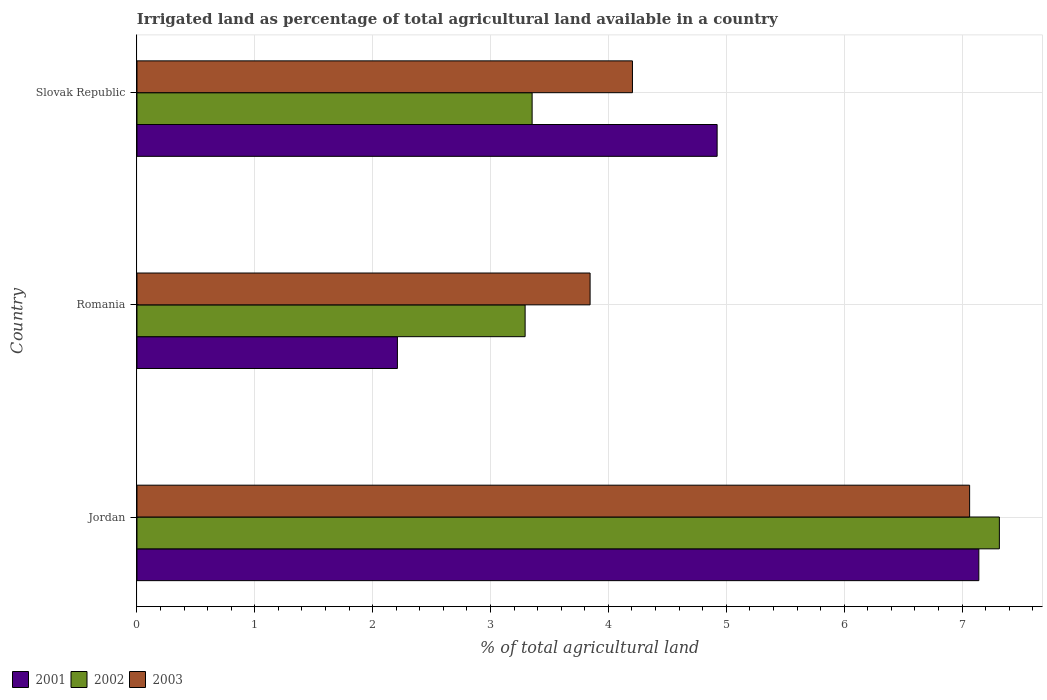Are the number of bars on each tick of the Y-axis equal?
Your answer should be compact. Yes. How many bars are there on the 2nd tick from the bottom?
Your answer should be very brief. 3. What is the label of the 2nd group of bars from the top?
Give a very brief answer. Romania. In how many cases, is the number of bars for a given country not equal to the number of legend labels?
Provide a succinct answer. 0. What is the percentage of irrigated land in 2003 in Jordan?
Keep it short and to the point. 7.06. Across all countries, what is the maximum percentage of irrigated land in 2001?
Your response must be concise. 7.14. Across all countries, what is the minimum percentage of irrigated land in 2001?
Provide a short and direct response. 2.21. In which country was the percentage of irrigated land in 2002 maximum?
Your answer should be very brief. Jordan. In which country was the percentage of irrigated land in 2003 minimum?
Make the answer very short. Romania. What is the total percentage of irrigated land in 2003 in the graph?
Make the answer very short. 15.11. What is the difference between the percentage of irrigated land in 2002 in Jordan and that in Slovak Republic?
Your answer should be compact. 3.96. What is the difference between the percentage of irrigated land in 2001 in Romania and the percentage of irrigated land in 2002 in Slovak Republic?
Provide a short and direct response. -1.14. What is the average percentage of irrigated land in 2002 per country?
Your answer should be compact. 4.65. What is the difference between the percentage of irrigated land in 2003 and percentage of irrigated land in 2002 in Slovak Republic?
Offer a very short reply. 0.85. What is the ratio of the percentage of irrigated land in 2003 in Romania to that in Slovak Republic?
Ensure brevity in your answer.  0.91. Is the difference between the percentage of irrigated land in 2003 in Jordan and Slovak Republic greater than the difference between the percentage of irrigated land in 2002 in Jordan and Slovak Republic?
Provide a short and direct response. No. What is the difference between the highest and the second highest percentage of irrigated land in 2001?
Your answer should be compact. 2.22. What is the difference between the highest and the lowest percentage of irrigated land in 2002?
Ensure brevity in your answer.  4.02. What does the 1st bar from the top in Romania represents?
Provide a short and direct response. 2003. Is it the case that in every country, the sum of the percentage of irrigated land in 2001 and percentage of irrigated land in 2002 is greater than the percentage of irrigated land in 2003?
Your answer should be compact. Yes. How many bars are there?
Ensure brevity in your answer.  9. How many countries are there in the graph?
Keep it short and to the point. 3. Where does the legend appear in the graph?
Keep it short and to the point. Bottom left. What is the title of the graph?
Give a very brief answer. Irrigated land as percentage of total agricultural land available in a country. Does "1994" appear as one of the legend labels in the graph?
Give a very brief answer. No. What is the label or title of the X-axis?
Keep it short and to the point. % of total agricultural land. What is the % of total agricultural land of 2001 in Jordan?
Offer a very short reply. 7.14. What is the % of total agricultural land of 2002 in Jordan?
Your response must be concise. 7.32. What is the % of total agricultural land in 2003 in Jordan?
Provide a succinct answer. 7.06. What is the % of total agricultural land of 2001 in Romania?
Ensure brevity in your answer.  2.21. What is the % of total agricultural land of 2002 in Romania?
Give a very brief answer. 3.29. What is the % of total agricultural land in 2003 in Romania?
Your answer should be compact. 3.84. What is the % of total agricultural land in 2001 in Slovak Republic?
Ensure brevity in your answer.  4.92. What is the % of total agricultural land of 2002 in Slovak Republic?
Make the answer very short. 3.35. What is the % of total agricultural land in 2003 in Slovak Republic?
Make the answer very short. 4.2. Across all countries, what is the maximum % of total agricultural land of 2001?
Make the answer very short. 7.14. Across all countries, what is the maximum % of total agricultural land in 2002?
Give a very brief answer. 7.32. Across all countries, what is the maximum % of total agricultural land of 2003?
Ensure brevity in your answer.  7.06. Across all countries, what is the minimum % of total agricultural land in 2001?
Provide a short and direct response. 2.21. Across all countries, what is the minimum % of total agricultural land of 2002?
Your answer should be compact. 3.29. Across all countries, what is the minimum % of total agricultural land in 2003?
Keep it short and to the point. 3.84. What is the total % of total agricultural land in 2001 in the graph?
Ensure brevity in your answer.  14.28. What is the total % of total agricultural land of 2002 in the graph?
Offer a very short reply. 13.96. What is the total % of total agricultural land of 2003 in the graph?
Your answer should be compact. 15.11. What is the difference between the % of total agricultural land in 2001 in Jordan and that in Romania?
Your answer should be compact. 4.93. What is the difference between the % of total agricultural land in 2002 in Jordan and that in Romania?
Make the answer very short. 4.02. What is the difference between the % of total agricultural land of 2003 in Jordan and that in Romania?
Give a very brief answer. 3.22. What is the difference between the % of total agricultural land of 2001 in Jordan and that in Slovak Republic?
Your answer should be very brief. 2.22. What is the difference between the % of total agricultural land of 2002 in Jordan and that in Slovak Republic?
Keep it short and to the point. 3.96. What is the difference between the % of total agricultural land of 2003 in Jordan and that in Slovak Republic?
Provide a succinct answer. 2.86. What is the difference between the % of total agricultural land in 2001 in Romania and that in Slovak Republic?
Provide a succinct answer. -2.71. What is the difference between the % of total agricultural land in 2002 in Romania and that in Slovak Republic?
Give a very brief answer. -0.06. What is the difference between the % of total agricultural land in 2003 in Romania and that in Slovak Republic?
Provide a succinct answer. -0.36. What is the difference between the % of total agricultural land in 2001 in Jordan and the % of total agricultural land in 2002 in Romania?
Keep it short and to the point. 3.85. What is the difference between the % of total agricultural land in 2001 in Jordan and the % of total agricultural land in 2003 in Romania?
Make the answer very short. 3.3. What is the difference between the % of total agricultural land of 2002 in Jordan and the % of total agricultural land of 2003 in Romania?
Ensure brevity in your answer.  3.47. What is the difference between the % of total agricultural land in 2001 in Jordan and the % of total agricultural land in 2002 in Slovak Republic?
Your answer should be very brief. 3.79. What is the difference between the % of total agricultural land of 2001 in Jordan and the % of total agricultural land of 2003 in Slovak Republic?
Give a very brief answer. 2.94. What is the difference between the % of total agricultural land in 2002 in Jordan and the % of total agricultural land in 2003 in Slovak Republic?
Give a very brief answer. 3.11. What is the difference between the % of total agricultural land of 2001 in Romania and the % of total agricultural land of 2002 in Slovak Republic?
Ensure brevity in your answer.  -1.14. What is the difference between the % of total agricultural land in 2001 in Romania and the % of total agricultural land in 2003 in Slovak Republic?
Your answer should be very brief. -1.99. What is the difference between the % of total agricultural land of 2002 in Romania and the % of total agricultural land of 2003 in Slovak Republic?
Ensure brevity in your answer.  -0.91. What is the average % of total agricultural land of 2001 per country?
Your response must be concise. 4.76. What is the average % of total agricultural land of 2002 per country?
Provide a succinct answer. 4.65. What is the average % of total agricultural land of 2003 per country?
Provide a short and direct response. 5.04. What is the difference between the % of total agricultural land of 2001 and % of total agricultural land of 2002 in Jordan?
Keep it short and to the point. -0.17. What is the difference between the % of total agricultural land of 2001 and % of total agricultural land of 2003 in Jordan?
Offer a terse response. 0.08. What is the difference between the % of total agricultural land of 2002 and % of total agricultural land of 2003 in Jordan?
Your response must be concise. 0.25. What is the difference between the % of total agricultural land in 2001 and % of total agricultural land in 2002 in Romania?
Your response must be concise. -1.08. What is the difference between the % of total agricultural land of 2001 and % of total agricultural land of 2003 in Romania?
Provide a succinct answer. -1.63. What is the difference between the % of total agricultural land of 2002 and % of total agricultural land of 2003 in Romania?
Offer a very short reply. -0.55. What is the difference between the % of total agricultural land in 2001 and % of total agricultural land in 2002 in Slovak Republic?
Your response must be concise. 1.57. What is the difference between the % of total agricultural land in 2001 and % of total agricultural land in 2003 in Slovak Republic?
Your answer should be very brief. 0.72. What is the difference between the % of total agricultural land of 2002 and % of total agricultural land of 2003 in Slovak Republic?
Offer a very short reply. -0.85. What is the ratio of the % of total agricultural land in 2001 in Jordan to that in Romania?
Ensure brevity in your answer.  3.23. What is the ratio of the % of total agricultural land in 2002 in Jordan to that in Romania?
Give a very brief answer. 2.22. What is the ratio of the % of total agricultural land in 2003 in Jordan to that in Romania?
Your answer should be compact. 1.84. What is the ratio of the % of total agricultural land of 2001 in Jordan to that in Slovak Republic?
Your answer should be compact. 1.45. What is the ratio of the % of total agricultural land in 2002 in Jordan to that in Slovak Republic?
Offer a very short reply. 2.18. What is the ratio of the % of total agricultural land of 2003 in Jordan to that in Slovak Republic?
Ensure brevity in your answer.  1.68. What is the ratio of the % of total agricultural land of 2001 in Romania to that in Slovak Republic?
Your answer should be very brief. 0.45. What is the ratio of the % of total agricultural land in 2002 in Romania to that in Slovak Republic?
Provide a succinct answer. 0.98. What is the ratio of the % of total agricultural land of 2003 in Romania to that in Slovak Republic?
Your answer should be compact. 0.91. What is the difference between the highest and the second highest % of total agricultural land of 2001?
Offer a very short reply. 2.22. What is the difference between the highest and the second highest % of total agricultural land of 2002?
Offer a very short reply. 3.96. What is the difference between the highest and the second highest % of total agricultural land in 2003?
Your response must be concise. 2.86. What is the difference between the highest and the lowest % of total agricultural land in 2001?
Provide a short and direct response. 4.93. What is the difference between the highest and the lowest % of total agricultural land in 2002?
Your response must be concise. 4.02. What is the difference between the highest and the lowest % of total agricultural land of 2003?
Provide a short and direct response. 3.22. 